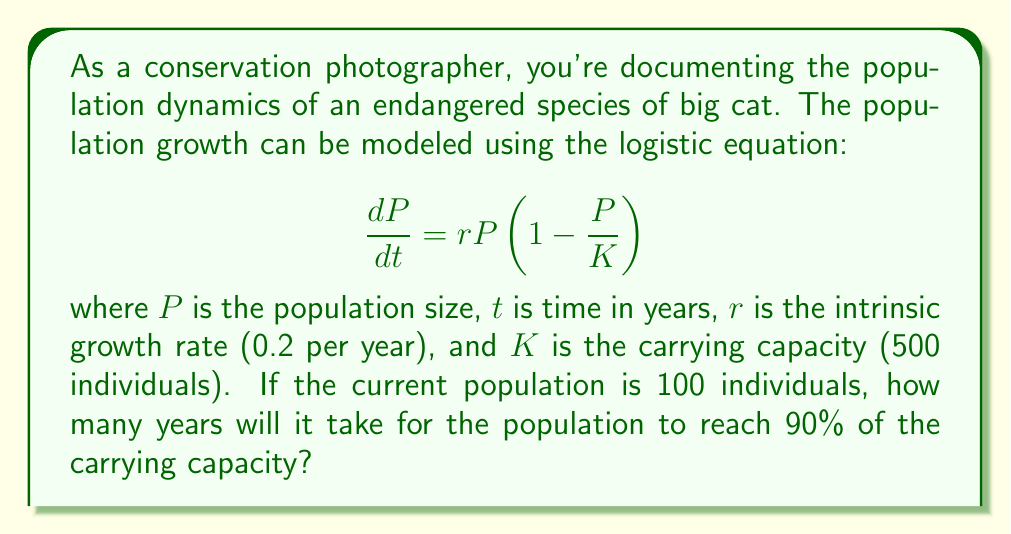Can you solve this math problem? To solve this problem, we need to use the integrated form of the logistic equation:

$$P(t) = \frac{K}{1 + (\frac{K}{P_0} - 1)e^{-rt}}$$

Where:
$P(t)$ is the population at time $t$
$K$ is the carrying capacity (500)
$P_0$ is the initial population (100)
$r$ is the intrinsic growth rate (0.2)

We want to find $t$ when $P(t) = 0.9K = 450$

Let's substitute the values:

$$450 = \frac{500}{1 + (\frac{500}{100} - 1)e^{-0.2t}}$$

Simplify:

$$450 = \frac{500}{1 + 4e^{-0.2t}}$$

Multiply both sides by $(1 + 4e^{-0.2t})$:

$$450(1 + 4e^{-0.2t}) = 500$$

Expand:

$$450 + 1800e^{-0.2t} = 500$$

Subtract 450 from both sides:

$$1800e^{-0.2t} = 50$$

Divide both sides by 1800:

$$e^{-0.2t} = \frac{1}{36}$$

Take the natural log of both sides:

$$-0.2t = \ln(\frac{1}{36})$$

$$-0.2t = -3.5835$$

Divide both sides by -0.2:

$$t = 17.9175$$

Therefore, it will take approximately 17.92 years for the population to reach 90% of the carrying capacity.
Answer: 17.92 years 